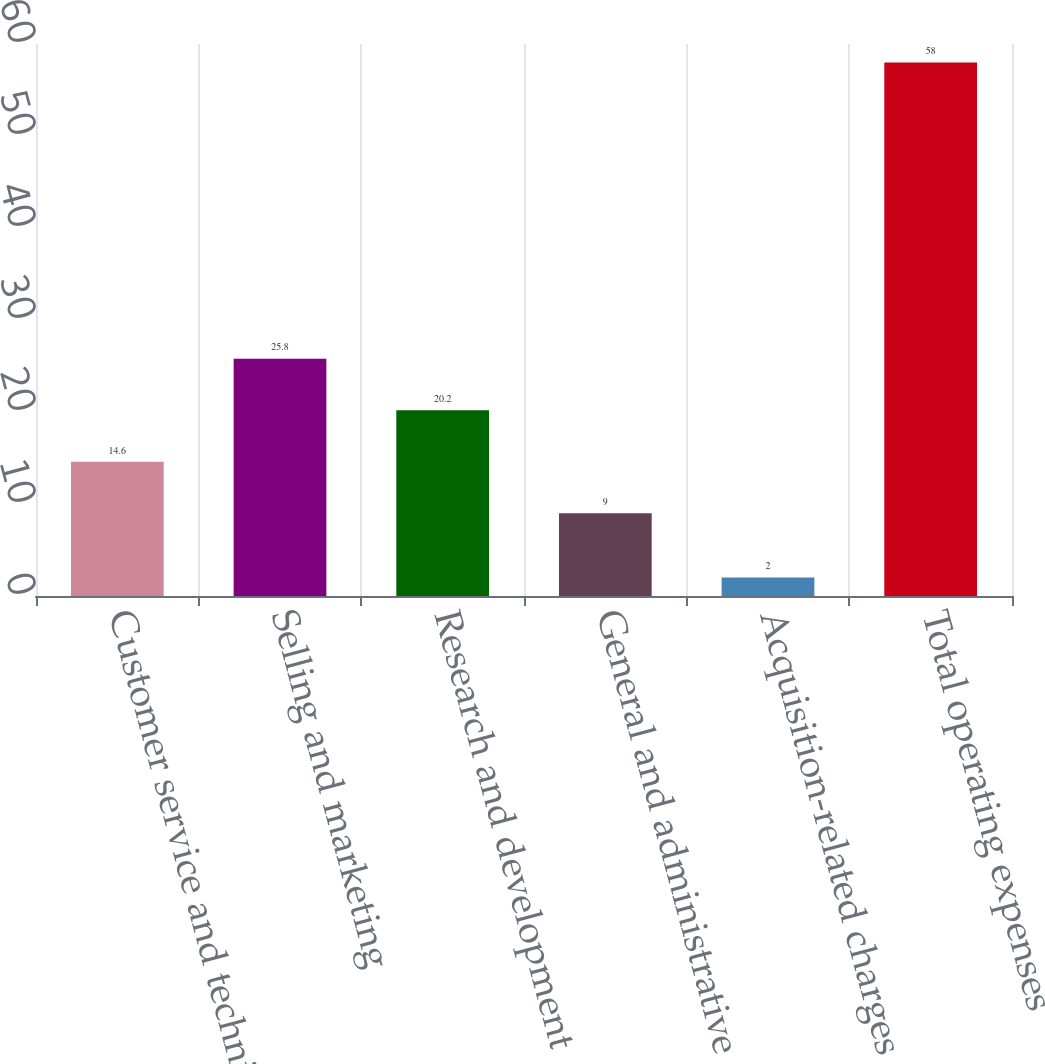Convert chart to OTSL. <chart><loc_0><loc_0><loc_500><loc_500><bar_chart><fcel>Customer service and technical<fcel>Selling and marketing<fcel>Research and development<fcel>General and administrative<fcel>Acquisition-related charges<fcel>Total operating expenses<nl><fcel>14.6<fcel>25.8<fcel>20.2<fcel>9<fcel>2<fcel>58<nl></chart> 